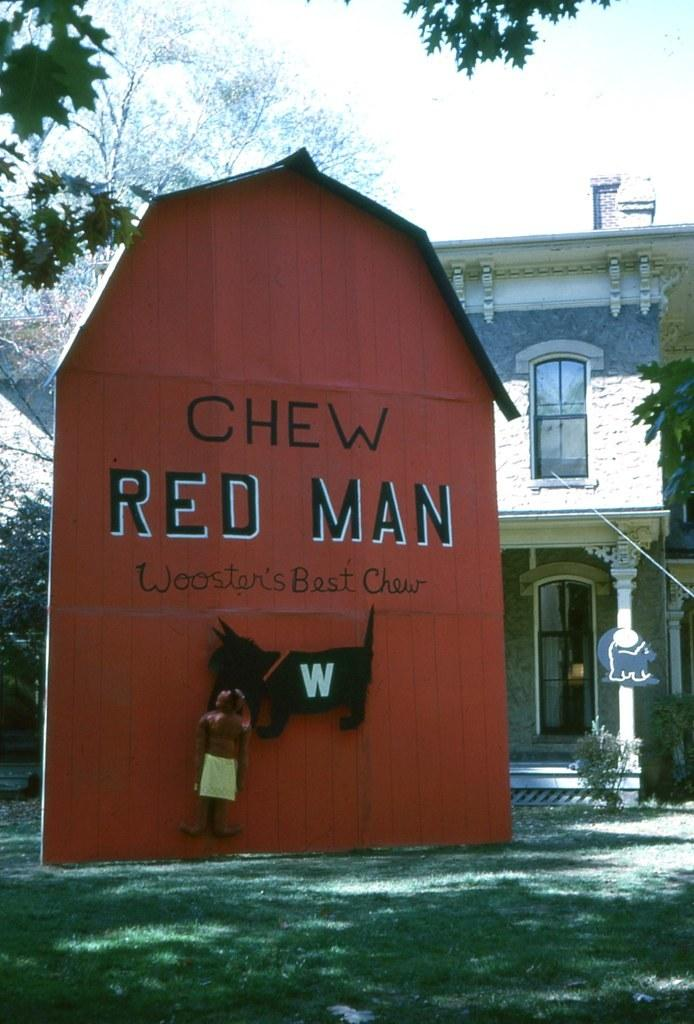What type of objects can be seen in the image? There are boards, a building, a pillar, plants, trees, and grass visible in the image. What is the purpose of the boards in the image? The boards have images on them, which suggests they might be used for displaying information or artwork. What is written on the red board? Something is written on the red board, but the specific content is not mentioned in the facts. What can be seen in the sky in the image? The sky is visible in the image, but no specific details about the sky are provided in the facts. How many mint leaves are growing on the trees in the image? There is no mention of mint leaves in the image, so it is not possible to determine their presence or quantity. 